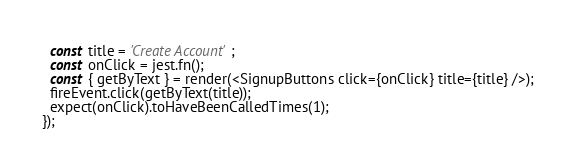Convert code to text. <code><loc_0><loc_0><loc_500><loc_500><_JavaScript_>  const title = 'Create Account';
  const onClick = jest.fn();
  const { getByText } = render(<SignupButtons click={onClick} title={title} />);
  fireEvent.click(getByText(title));
  expect(onClick).toHaveBeenCalledTimes(1);
});
</code> 